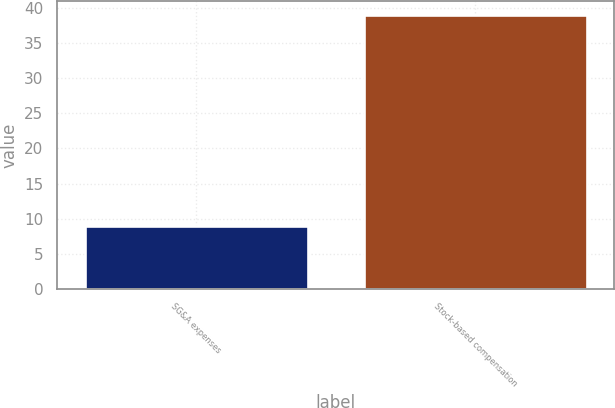<chart> <loc_0><loc_0><loc_500><loc_500><bar_chart><fcel>SG&A expenses<fcel>Stock-based compensation<nl><fcel>9<fcel>39<nl></chart> 